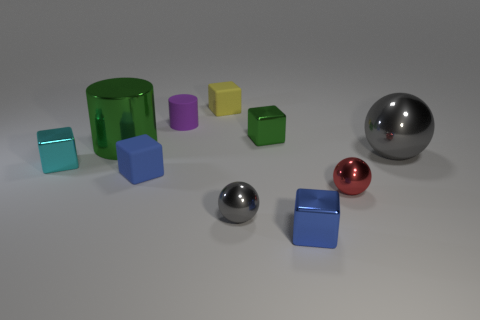Subtract all small green metal cubes. How many cubes are left? 4 Subtract all yellow blocks. How many blocks are left? 4 Subtract all brown cubes. Subtract all purple cylinders. How many cubes are left? 5 Subtract all balls. How many objects are left? 7 Subtract 0 cyan balls. How many objects are left? 10 Subtract all small purple rubber blocks. Subtract all big green metallic cylinders. How many objects are left? 9 Add 4 matte things. How many matte things are left? 7 Add 2 balls. How many balls exist? 5 